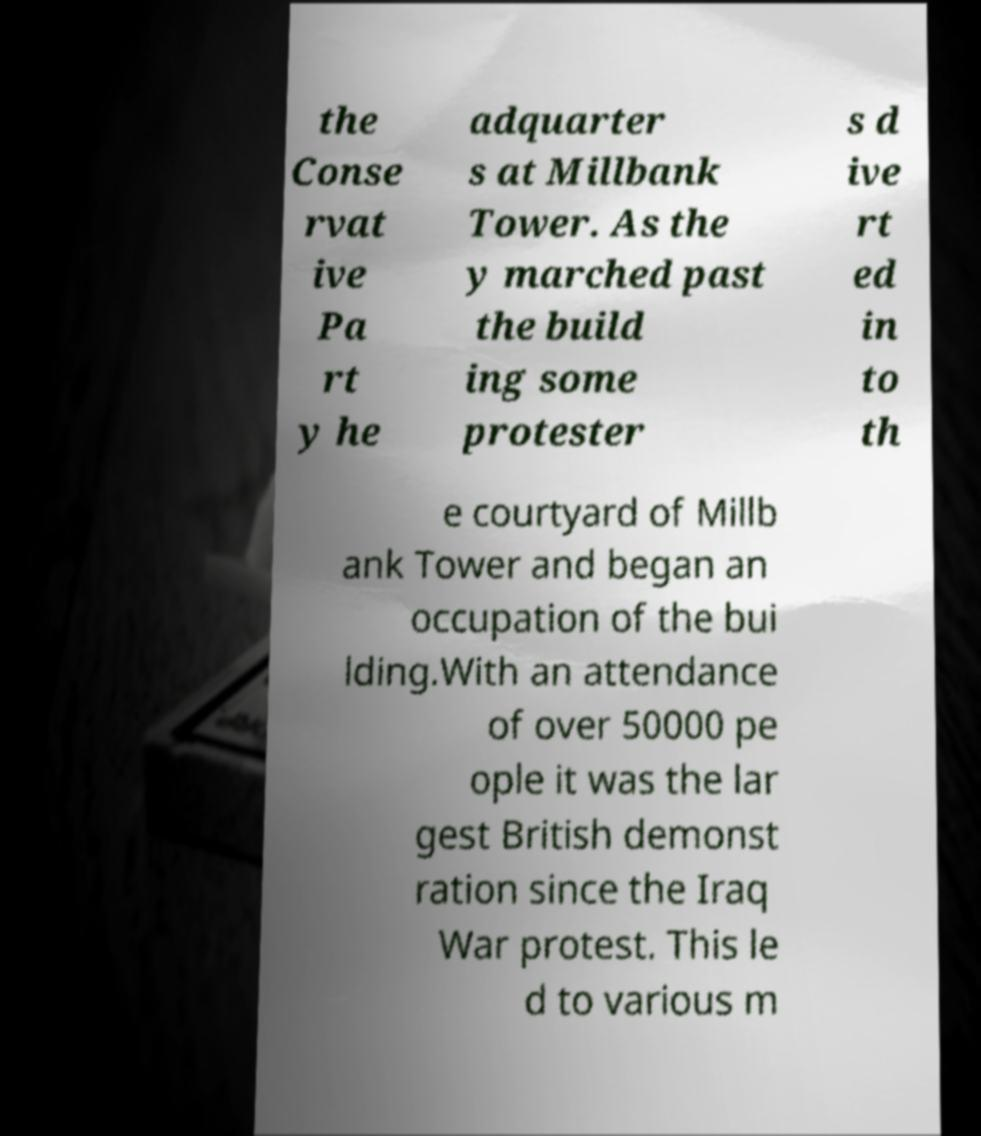There's text embedded in this image that I need extracted. Can you transcribe it verbatim? the Conse rvat ive Pa rt y he adquarter s at Millbank Tower. As the y marched past the build ing some protester s d ive rt ed in to th e courtyard of Millb ank Tower and began an occupation of the bui lding.With an attendance of over 50000 pe ople it was the lar gest British demonst ration since the Iraq War protest. This le d to various m 